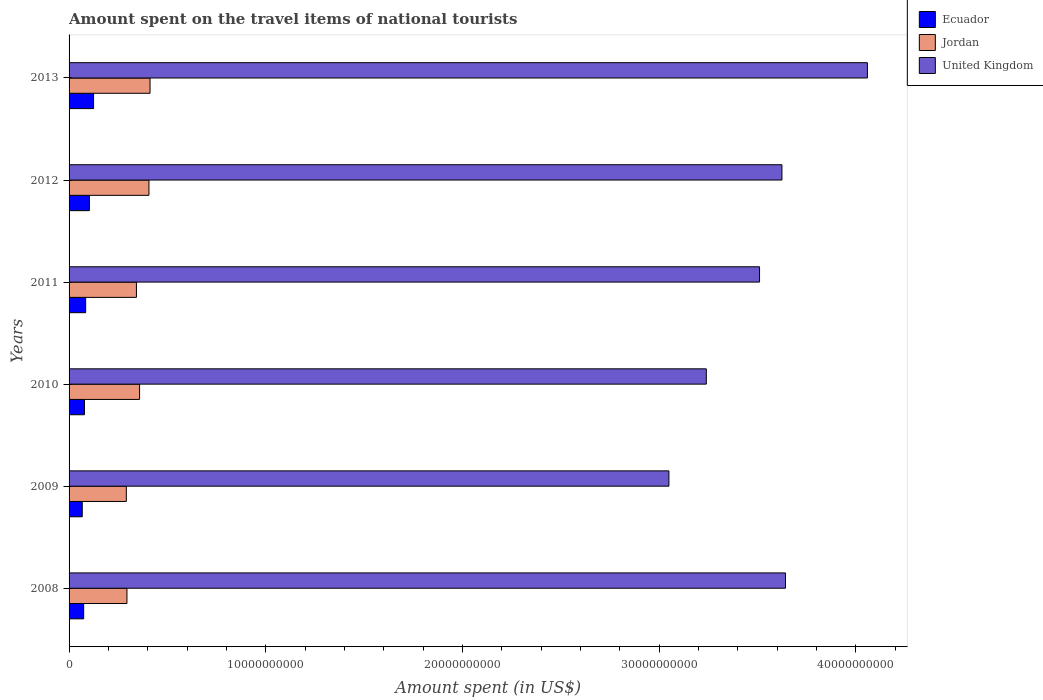Are the number of bars per tick equal to the number of legend labels?
Provide a short and direct response. Yes. How many bars are there on the 2nd tick from the bottom?
Your response must be concise. 3. What is the amount spent on the travel items of national tourists in Ecuador in 2009?
Offer a very short reply. 6.70e+08. Across all years, what is the maximum amount spent on the travel items of national tourists in Jordan?
Offer a very short reply. 4.12e+09. Across all years, what is the minimum amount spent on the travel items of national tourists in Ecuador?
Give a very brief answer. 6.70e+08. In which year was the amount spent on the travel items of national tourists in United Kingdom maximum?
Offer a terse response. 2013. What is the total amount spent on the travel items of national tourists in United Kingdom in the graph?
Give a very brief answer. 2.11e+11. What is the difference between the amount spent on the travel items of national tourists in United Kingdom in 2009 and that in 2012?
Keep it short and to the point. -5.75e+09. What is the difference between the amount spent on the travel items of national tourists in Ecuador in 2009 and the amount spent on the travel items of national tourists in Jordan in 2008?
Ensure brevity in your answer.  -2.27e+09. What is the average amount spent on the travel items of national tourists in United Kingdom per year?
Give a very brief answer. 3.52e+1. In the year 2008, what is the difference between the amount spent on the travel items of national tourists in United Kingdom and amount spent on the travel items of national tourists in Ecuador?
Give a very brief answer. 3.57e+1. In how many years, is the amount spent on the travel items of national tourists in Jordan greater than 10000000000 US$?
Your answer should be compact. 0. What is the ratio of the amount spent on the travel items of national tourists in United Kingdom in 2010 to that in 2013?
Make the answer very short. 0.8. Is the amount spent on the travel items of national tourists in United Kingdom in 2010 less than that in 2013?
Your answer should be very brief. Yes. Is the difference between the amount spent on the travel items of national tourists in United Kingdom in 2009 and 2012 greater than the difference between the amount spent on the travel items of national tourists in Ecuador in 2009 and 2012?
Your response must be concise. No. What is the difference between the highest and the second highest amount spent on the travel items of national tourists in United Kingdom?
Your answer should be compact. 4.16e+09. What is the difference between the highest and the lowest amount spent on the travel items of national tourists in Ecuador?
Keep it short and to the point. 5.76e+08. In how many years, is the amount spent on the travel items of national tourists in Jordan greater than the average amount spent on the travel items of national tourists in Jordan taken over all years?
Make the answer very short. 3. What does the 1st bar from the top in 2012 represents?
Ensure brevity in your answer.  United Kingdom. What does the 1st bar from the bottom in 2013 represents?
Your response must be concise. Ecuador. Is it the case that in every year, the sum of the amount spent on the travel items of national tourists in Jordan and amount spent on the travel items of national tourists in Ecuador is greater than the amount spent on the travel items of national tourists in United Kingdom?
Your response must be concise. No. How many years are there in the graph?
Provide a short and direct response. 6. What is the title of the graph?
Provide a succinct answer. Amount spent on the travel items of national tourists. What is the label or title of the X-axis?
Keep it short and to the point. Amount spent (in US$). What is the Amount spent (in US$) of Ecuador in 2008?
Give a very brief answer. 7.42e+08. What is the Amount spent (in US$) of Jordan in 2008?
Your answer should be very brief. 2.94e+09. What is the Amount spent (in US$) of United Kingdom in 2008?
Keep it short and to the point. 3.64e+1. What is the Amount spent (in US$) in Ecuador in 2009?
Provide a succinct answer. 6.70e+08. What is the Amount spent (in US$) of Jordan in 2009?
Provide a short and direct response. 2.91e+09. What is the Amount spent (in US$) in United Kingdom in 2009?
Give a very brief answer. 3.05e+1. What is the Amount spent (in US$) of Ecuador in 2010?
Provide a short and direct response. 7.81e+08. What is the Amount spent (in US$) in Jordan in 2010?
Ensure brevity in your answer.  3.58e+09. What is the Amount spent (in US$) in United Kingdom in 2010?
Provide a succinct answer. 3.24e+1. What is the Amount spent (in US$) in Ecuador in 2011?
Provide a short and direct response. 8.43e+08. What is the Amount spent (in US$) in Jordan in 2011?
Provide a short and direct response. 3.42e+09. What is the Amount spent (in US$) of United Kingdom in 2011?
Ensure brevity in your answer.  3.51e+1. What is the Amount spent (in US$) in Ecuador in 2012?
Give a very brief answer. 1.03e+09. What is the Amount spent (in US$) in Jordan in 2012?
Ensure brevity in your answer.  4.06e+09. What is the Amount spent (in US$) of United Kingdom in 2012?
Keep it short and to the point. 3.62e+1. What is the Amount spent (in US$) of Ecuador in 2013?
Provide a short and direct response. 1.25e+09. What is the Amount spent (in US$) of Jordan in 2013?
Your response must be concise. 4.12e+09. What is the Amount spent (in US$) of United Kingdom in 2013?
Your answer should be very brief. 4.06e+1. Across all years, what is the maximum Amount spent (in US$) in Ecuador?
Your response must be concise. 1.25e+09. Across all years, what is the maximum Amount spent (in US$) of Jordan?
Your answer should be very brief. 4.12e+09. Across all years, what is the maximum Amount spent (in US$) in United Kingdom?
Give a very brief answer. 4.06e+1. Across all years, what is the minimum Amount spent (in US$) in Ecuador?
Make the answer very short. 6.70e+08. Across all years, what is the minimum Amount spent (in US$) of Jordan?
Make the answer very short. 2.91e+09. Across all years, what is the minimum Amount spent (in US$) of United Kingdom?
Offer a terse response. 3.05e+1. What is the total Amount spent (in US$) in Ecuador in the graph?
Offer a terse response. 5.32e+09. What is the total Amount spent (in US$) in Jordan in the graph?
Offer a very short reply. 2.10e+1. What is the total Amount spent (in US$) in United Kingdom in the graph?
Offer a terse response. 2.11e+11. What is the difference between the Amount spent (in US$) of Ecuador in 2008 and that in 2009?
Make the answer very short. 7.20e+07. What is the difference between the Amount spent (in US$) of Jordan in 2008 and that in 2009?
Offer a terse response. 3.20e+07. What is the difference between the Amount spent (in US$) of United Kingdom in 2008 and that in 2009?
Your answer should be compact. 5.93e+09. What is the difference between the Amount spent (in US$) of Ecuador in 2008 and that in 2010?
Offer a terse response. -3.90e+07. What is the difference between the Amount spent (in US$) of Jordan in 2008 and that in 2010?
Provide a succinct answer. -6.42e+08. What is the difference between the Amount spent (in US$) of United Kingdom in 2008 and that in 2010?
Keep it short and to the point. 4.02e+09. What is the difference between the Amount spent (in US$) of Ecuador in 2008 and that in 2011?
Offer a very short reply. -1.01e+08. What is the difference between the Amount spent (in US$) in Jordan in 2008 and that in 2011?
Your answer should be very brief. -4.82e+08. What is the difference between the Amount spent (in US$) in United Kingdom in 2008 and that in 2011?
Offer a terse response. 1.32e+09. What is the difference between the Amount spent (in US$) of Ecuador in 2008 and that in 2012?
Make the answer very short. -2.91e+08. What is the difference between the Amount spent (in US$) of Jordan in 2008 and that in 2012?
Provide a short and direct response. -1.12e+09. What is the difference between the Amount spent (in US$) in United Kingdom in 2008 and that in 2012?
Offer a terse response. 1.80e+08. What is the difference between the Amount spent (in US$) in Ecuador in 2008 and that in 2013?
Provide a short and direct response. -5.04e+08. What is the difference between the Amount spent (in US$) of Jordan in 2008 and that in 2013?
Your answer should be compact. -1.17e+09. What is the difference between the Amount spent (in US$) of United Kingdom in 2008 and that in 2013?
Your answer should be compact. -4.16e+09. What is the difference between the Amount spent (in US$) of Ecuador in 2009 and that in 2010?
Make the answer very short. -1.11e+08. What is the difference between the Amount spent (in US$) of Jordan in 2009 and that in 2010?
Make the answer very short. -6.74e+08. What is the difference between the Amount spent (in US$) in United Kingdom in 2009 and that in 2010?
Give a very brief answer. -1.90e+09. What is the difference between the Amount spent (in US$) of Ecuador in 2009 and that in 2011?
Keep it short and to the point. -1.73e+08. What is the difference between the Amount spent (in US$) in Jordan in 2009 and that in 2011?
Your answer should be compact. -5.14e+08. What is the difference between the Amount spent (in US$) of United Kingdom in 2009 and that in 2011?
Offer a terse response. -4.61e+09. What is the difference between the Amount spent (in US$) of Ecuador in 2009 and that in 2012?
Your response must be concise. -3.63e+08. What is the difference between the Amount spent (in US$) in Jordan in 2009 and that in 2012?
Provide a short and direct response. -1.15e+09. What is the difference between the Amount spent (in US$) of United Kingdom in 2009 and that in 2012?
Provide a short and direct response. -5.75e+09. What is the difference between the Amount spent (in US$) of Ecuador in 2009 and that in 2013?
Your answer should be compact. -5.76e+08. What is the difference between the Amount spent (in US$) in Jordan in 2009 and that in 2013?
Your answer should be very brief. -1.21e+09. What is the difference between the Amount spent (in US$) of United Kingdom in 2009 and that in 2013?
Your answer should be compact. -1.01e+1. What is the difference between the Amount spent (in US$) of Ecuador in 2010 and that in 2011?
Provide a short and direct response. -6.20e+07. What is the difference between the Amount spent (in US$) in Jordan in 2010 and that in 2011?
Provide a succinct answer. 1.60e+08. What is the difference between the Amount spent (in US$) in United Kingdom in 2010 and that in 2011?
Your answer should be compact. -2.71e+09. What is the difference between the Amount spent (in US$) in Ecuador in 2010 and that in 2012?
Offer a very short reply. -2.52e+08. What is the difference between the Amount spent (in US$) of Jordan in 2010 and that in 2012?
Offer a terse response. -4.76e+08. What is the difference between the Amount spent (in US$) of United Kingdom in 2010 and that in 2012?
Your response must be concise. -3.84e+09. What is the difference between the Amount spent (in US$) of Ecuador in 2010 and that in 2013?
Make the answer very short. -4.65e+08. What is the difference between the Amount spent (in US$) in Jordan in 2010 and that in 2013?
Ensure brevity in your answer.  -5.32e+08. What is the difference between the Amount spent (in US$) in United Kingdom in 2010 and that in 2013?
Ensure brevity in your answer.  -8.19e+09. What is the difference between the Amount spent (in US$) of Ecuador in 2011 and that in 2012?
Your answer should be very brief. -1.90e+08. What is the difference between the Amount spent (in US$) in Jordan in 2011 and that in 2012?
Make the answer very short. -6.36e+08. What is the difference between the Amount spent (in US$) of United Kingdom in 2011 and that in 2012?
Make the answer very short. -1.14e+09. What is the difference between the Amount spent (in US$) in Ecuador in 2011 and that in 2013?
Your answer should be very brief. -4.03e+08. What is the difference between the Amount spent (in US$) of Jordan in 2011 and that in 2013?
Your response must be concise. -6.92e+08. What is the difference between the Amount spent (in US$) of United Kingdom in 2011 and that in 2013?
Offer a very short reply. -5.48e+09. What is the difference between the Amount spent (in US$) of Ecuador in 2012 and that in 2013?
Make the answer very short. -2.13e+08. What is the difference between the Amount spent (in US$) of Jordan in 2012 and that in 2013?
Ensure brevity in your answer.  -5.60e+07. What is the difference between the Amount spent (in US$) of United Kingdom in 2012 and that in 2013?
Your answer should be very brief. -4.34e+09. What is the difference between the Amount spent (in US$) of Ecuador in 2008 and the Amount spent (in US$) of Jordan in 2009?
Provide a succinct answer. -2.17e+09. What is the difference between the Amount spent (in US$) of Ecuador in 2008 and the Amount spent (in US$) of United Kingdom in 2009?
Provide a succinct answer. -2.98e+1. What is the difference between the Amount spent (in US$) in Jordan in 2008 and the Amount spent (in US$) in United Kingdom in 2009?
Offer a terse response. -2.76e+1. What is the difference between the Amount spent (in US$) of Ecuador in 2008 and the Amount spent (in US$) of Jordan in 2010?
Ensure brevity in your answer.  -2.84e+09. What is the difference between the Amount spent (in US$) in Ecuador in 2008 and the Amount spent (in US$) in United Kingdom in 2010?
Give a very brief answer. -3.17e+1. What is the difference between the Amount spent (in US$) of Jordan in 2008 and the Amount spent (in US$) of United Kingdom in 2010?
Your answer should be very brief. -2.95e+1. What is the difference between the Amount spent (in US$) in Ecuador in 2008 and the Amount spent (in US$) in Jordan in 2011?
Give a very brief answer. -2.68e+09. What is the difference between the Amount spent (in US$) in Ecuador in 2008 and the Amount spent (in US$) in United Kingdom in 2011?
Ensure brevity in your answer.  -3.44e+1. What is the difference between the Amount spent (in US$) in Jordan in 2008 and the Amount spent (in US$) in United Kingdom in 2011?
Offer a terse response. -3.22e+1. What is the difference between the Amount spent (in US$) of Ecuador in 2008 and the Amount spent (in US$) of Jordan in 2012?
Give a very brief answer. -3.32e+09. What is the difference between the Amount spent (in US$) in Ecuador in 2008 and the Amount spent (in US$) in United Kingdom in 2012?
Provide a succinct answer. -3.55e+1. What is the difference between the Amount spent (in US$) in Jordan in 2008 and the Amount spent (in US$) in United Kingdom in 2012?
Your answer should be compact. -3.33e+1. What is the difference between the Amount spent (in US$) of Ecuador in 2008 and the Amount spent (in US$) of Jordan in 2013?
Give a very brief answer. -3.38e+09. What is the difference between the Amount spent (in US$) in Ecuador in 2008 and the Amount spent (in US$) in United Kingdom in 2013?
Your answer should be compact. -3.98e+1. What is the difference between the Amount spent (in US$) of Jordan in 2008 and the Amount spent (in US$) of United Kingdom in 2013?
Your response must be concise. -3.76e+1. What is the difference between the Amount spent (in US$) in Ecuador in 2009 and the Amount spent (in US$) in Jordan in 2010?
Your answer should be very brief. -2.92e+09. What is the difference between the Amount spent (in US$) of Ecuador in 2009 and the Amount spent (in US$) of United Kingdom in 2010?
Your response must be concise. -3.17e+1. What is the difference between the Amount spent (in US$) in Jordan in 2009 and the Amount spent (in US$) in United Kingdom in 2010?
Give a very brief answer. -2.95e+1. What is the difference between the Amount spent (in US$) in Ecuador in 2009 and the Amount spent (in US$) in Jordan in 2011?
Make the answer very short. -2.76e+09. What is the difference between the Amount spent (in US$) of Ecuador in 2009 and the Amount spent (in US$) of United Kingdom in 2011?
Your answer should be very brief. -3.44e+1. What is the difference between the Amount spent (in US$) in Jordan in 2009 and the Amount spent (in US$) in United Kingdom in 2011?
Offer a very short reply. -3.22e+1. What is the difference between the Amount spent (in US$) in Ecuador in 2009 and the Amount spent (in US$) in Jordan in 2012?
Provide a succinct answer. -3.39e+09. What is the difference between the Amount spent (in US$) in Ecuador in 2009 and the Amount spent (in US$) in United Kingdom in 2012?
Offer a terse response. -3.56e+1. What is the difference between the Amount spent (in US$) in Jordan in 2009 and the Amount spent (in US$) in United Kingdom in 2012?
Provide a succinct answer. -3.33e+1. What is the difference between the Amount spent (in US$) in Ecuador in 2009 and the Amount spent (in US$) in Jordan in 2013?
Give a very brief answer. -3.45e+09. What is the difference between the Amount spent (in US$) in Ecuador in 2009 and the Amount spent (in US$) in United Kingdom in 2013?
Offer a very short reply. -3.99e+1. What is the difference between the Amount spent (in US$) of Jordan in 2009 and the Amount spent (in US$) of United Kingdom in 2013?
Your answer should be very brief. -3.77e+1. What is the difference between the Amount spent (in US$) of Ecuador in 2010 and the Amount spent (in US$) of Jordan in 2011?
Your answer should be very brief. -2.64e+09. What is the difference between the Amount spent (in US$) of Ecuador in 2010 and the Amount spent (in US$) of United Kingdom in 2011?
Provide a short and direct response. -3.43e+1. What is the difference between the Amount spent (in US$) in Jordan in 2010 and the Amount spent (in US$) in United Kingdom in 2011?
Your answer should be compact. -3.15e+1. What is the difference between the Amount spent (in US$) of Ecuador in 2010 and the Amount spent (in US$) of Jordan in 2012?
Your answer should be compact. -3.28e+09. What is the difference between the Amount spent (in US$) of Ecuador in 2010 and the Amount spent (in US$) of United Kingdom in 2012?
Offer a terse response. -3.55e+1. What is the difference between the Amount spent (in US$) of Jordan in 2010 and the Amount spent (in US$) of United Kingdom in 2012?
Ensure brevity in your answer.  -3.27e+1. What is the difference between the Amount spent (in US$) in Ecuador in 2010 and the Amount spent (in US$) in Jordan in 2013?
Offer a very short reply. -3.34e+09. What is the difference between the Amount spent (in US$) of Ecuador in 2010 and the Amount spent (in US$) of United Kingdom in 2013?
Make the answer very short. -3.98e+1. What is the difference between the Amount spent (in US$) of Jordan in 2010 and the Amount spent (in US$) of United Kingdom in 2013?
Your answer should be very brief. -3.70e+1. What is the difference between the Amount spent (in US$) of Ecuador in 2011 and the Amount spent (in US$) of Jordan in 2012?
Offer a very short reply. -3.22e+09. What is the difference between the Amount spent (in US$) in Ecuador in 2011 and the Amount spent (in US$) in United Kingdom in 2012?
Your answer should be compact. -3.54e+1. What is the difference between the Amount spent (in US$) of Jordan in 2011 and the Amount spent (in US$) of United Kingdom in 2012?
Offer a very short reply. -3.28e+1. What is the difference between the Amount spent (in US$) of Ecuador in 2011 and the Amount spent (in US$) of Jordan in 2013?
Offer a very short reply. -3.27e+09. What is the difference between the Amount spent (in US$) of Ecuador in 2011 and the Amount spent (in US$) of United Kingdom in 2013?
Provide a succinct answer. -3.97e+1. What is the difference between the Amount spent (in US$) of Jordan in 2011 and the Amount spent (in US$) of United Kingdom in 2013?
Your answer should be compact. -3.72e+1. What is the difference between the Amount spent (in US$) of Ecuador in 2012 and the Amount spent (in US$) of Jordan in 2013?
Provide a short and direct response. -3.08e+09. What is the difference between the Amount spent (in US$) of Ecuador in 2012 and the Amount spent (in US$) of United Kingdom in 2013?
Make the answer very short. -3.96e+1. What is the difference between the Amount spent (in US$) in Jordan in 2012 and the Amount spent (in US$) in United Kingdom in 2013?
Offer a terse response. -3.65e+1. What is the average Amount spent (in US$) in Ecuador per year?
Provide a short and direct response. 8.86e+08. What is the average Amount spent (in US$) in Jordan per year?
Give a very brief answer. 3.51e+09. What is the average Amount spent (in US$) of United Kingdom per year?
Your response must be concise. 3.52e+1. In the year 2008, what is the difference between the Amount spent (in US$) in Ecuador and Amount spent (in US$) in Jordan?
Provide a short and direct response. -2.20e+09. In the year 2008, what is the difference between the Amount spent (in US$) of Ecuador and Amount spent (in US$) of United Kingdom?
Keep it short and to the point. -3.57e+1. In the year 2008, what is the difference between the Amount spent (in US$) in Jordan and Amount spent (in US$) in United Kingdom?
Your answer should be compact. -3.35e+1. In the year 2009, what is the difference between the Amount spent (in US$) in Ecuador and Amount spent (in US$) in Jordan?
Provide a short and direct response. -2.24e+09. In the year 2009, what is the difference between the Amount spent (in US$) in Ecuador and Amount spent (in US$) in United Kingdom?
Give a very brief answer. -2.98e+1. In the year 2009, what is the difference between the Amount spent (in US$) of Jordan and Amount spent (in US$) of United Kingdom?
Your answer should be very brief. -2.76e+1. In the year 2010, what is the difference between the Amount spent (in US$) of Ecuador and Amount spent (in US$) of Jordan?
Your response must be concise. -2.80e+09. In the year 2010, what is the difference between the Amount spent (in US$) in Ecuador and Amount spent (in US$) in United Kingdom?
Provide a succinct answer. -3.16e+1. In the year 2010, what is the difference between the Amount spent (in US$) in Jordan and Amount spent (in US$) in United Kingdom?
Offer a terse response. -2.88e+1. In the year 2011, what is the difference between the Amount spent (in US$) of Ecuador and Amount spent (in US$) of Jordan?
Give a very brief answer. -2.58e+09. In the year 2011, what is the difference between the Amount spent (in US$) in Ecuador and Amount spent (in US$) in United Kingdom?
Provide a short and direct response. -3.43e+1. In the year 2011, what is the difference between the Amount spent (in US$) of Jordan and Amount spent (in US$) of United Kingdom?
Provide a short and direct response. -3.17e+1. In the year 2012, what is the difference between the Amount spent (in US$) of Ecuador and Amount spent (in US$) of Jordan?
Keep it short and to the point. -3.03e+09. In the year 2012, what is the difference between the Amount spent (in US$) in Ecuador and Amount spent (in US$) in United Kingdom?
Offer a very short reply. -3.52e+1. In the year 2012, what is the difference between the Amount spent (in US$) of Jordan and Amount spent (in US$) of United Kingdom?
Offer a very short reply. -3.22e+1. In the year 2013, what is the difference between the Amount spent (in US$) in Ecuador and Amount spent (in US$) in Jordan?
Provide a short and direct response. -2.87e+09. In the year 2013, what is the difference between the Amount spent (in US$) in Ecuador and Amount spent (in US$) in United Kingdom?
Provide a succinct answer. -3.93e+1. In the year 2013, what is the difference between the Amount spent (in US$) of Jordan and Amount spent (in US$) of United Kingdom?
Your answer should be very brief. -3.65e+1. What is the ratio of the Amount spent (in US$) in Ecuador in 2008 to that in 2009?
Make the answer very short. 1.11. What is the ratio of the Amount spent (in US$) of Jordan in 2008 to that in 2009?
Offer a very short reply. 1.01. What is the ratio of the Amount spent (in US$) of United Kingdom in 2008 to that in 2009?
Provide a short and direct response. 1.19. What is the ratio of the Amount spent (in US$) of Ecuador in 2008 to that in 2010?
Provide a short and direct response. 0.95. What is the ratio of the Amount spent (in US$) in Jordan in 2008 to that in 2010?
Your answer should be very brief. 0.82. What is the ratio of the Amount spent (in US$) in United Kingdom in 2008 to that in 2010?
Provide a short and direct response. 1.12. What is the ratio of the Amount spent (in US$) in Ecuador in 2008 to that in 2011?
Provide a succinct answer. 0.88. What is the ratio of the Amount spent (in US$) in Jordan in 2008 to that in 2011?
Your response must be concise. 0.86. What is the ratio of the Amount spent (in US$) of United Kingdom in 2008 to that in 2011?
Give a very brief answer. 1.04. What is the ratio of the Amount spent (in US$) of Ecuador in 2008 to that in 2012?
Provide a short and direct response. 0.72. What is the ratio of the Amount spent (in US$) of Jordan in 2008 to that in 2012?
Ensure brevity in your answer.  0.72. What is the ratio of the Amount spent (in US$) in United Kingdom in 2008 to that in 2012?
Your response must be concise. 1. What is the ratio of the Amount spent (in US$) in Ecuador in 2008 to that in 2013?
Your answer should be compact. 0.6. What is the ratio of the Amount spent (in US$) in Jordan in 2008 to that in 2013?
Give a very brief answer. 0.71. What is the ratio of the Amount spent (in US$) in United Kingdom in 2008 to that in 2013?
Provide a succinct answer. 0.9. What is the ratio of the Amount spent (in US$) of Ecuador in 2009 to that in 2010?
Your response must be concise. 0.86. What is the ratio of the Amount spent (in US$) in Jordan in 2009 to that in 2010?
Offer a very short reply. 0.81. What is the ratio of the Amount spent (in US$) of United Kingdom in 2009 to that in 2010?
Provide a short and direct response. 0.94. What is the ratio of the Amount spent (in US$) in Ecuador in 2009 to that in 2011?
Offer a very short reply. 0.79. What is the ratio of the Amount spent (in US$) of Jordan in 2009 to that in 2011?
Ensure brevity in your answer.  0.85. What is the ratio of the Amount spent (in US$) in United Kingdom in 2009 to that in 2011?
Your answer should be very brief. 0.87. What is the ratio of the Amount spent (in US$) in Ecuador in 2009 to that in 2012?
Provide a succinct answer. 0.65. What is the ratio of the Amount spent (in US$) of Jordan in 2009 to that in 2012?
Ensure brevity in your answer.  0.72. What is the ratio of the Amount spent (in US$) in United Kingdom in 2009 to that in 2012?
Your response must be concise. 0.84. What is the ratio of the Amount spent (in US$) in Ecuador in 2009 to that in 2013?
Your answer should be very brief. 0.54. What is the ratio of the Amount spent (in US$) of Jordan in 2009 to that in 2013?
Your answer should be very brief. 0.71. What is the ratio of the Amount spent (in US$) of United Kingdom in 2009 to that in 2013?
Give a very brief answer. 0.75. What is the ratio of the Amount spent (in US$) of Ecuador in 2010 to that in 2011?
Offer a terse response. 0.93. What is the ratio of the Amount spent (in US$) of Jordan in 2010 to that in 2011?
Offer a terse response. 1.05. What is the ratio of the Amount spent (in US$) in United Kingdom in 2010 to that in 2011?
Your answer should be compact. 0.92. What is the ratio of the Amount spent (in US$) of Ecuador in 2010 to that in 2012?
Your answer should be very brief. 0.76. What is the ratio of the Amount spent (in US$) of Jordan in 2010 to that in 2012?
Give a very brief answer. 0.88. What is the ratio of the Amount spent (in US$) of United Kingdom in 2010 to that in 2012?
Provide a short and direct response. 0.89. What is the ratio of the Amount spent (in US$) of Ecuador in 2010 to that in 2013?
Offer a terse response. 0.63. What is the ratio of the Amount spent (in US$) of Jordan in 2010 to that in 2013?
Ensure brevity in your answer.  0.87. What is the ratio of the Amount spent (in US$) in United Kingdom in 2010 to that in 2013?
Your answer should be compact. 0.8. What is the ratio of the Amount spent (in US$) of Ecuador in 2011 to that in 2012?
Provide a succinct answer. 0.82. What is the ratio of the Amount spent (in US$) of Jordan in 2011 to that in 2012?
Ensure brevity in your answer.  0.84. What is the ratio of the Amount spent (in US$) in United Kingdom in 2011 to that in 2012?
Provide a short and direct response. 0.97. What is the ratio of the Amount spent (in US$) of Ecuador in 2011 to that in 2013?
Provide a succinct answer. 0.68. What is the ratio of the Amount spent (in US$) of Jordan in 2011 to that in 2013?
Provide a short and direct response. 0.83. What is the ratio of the Amount spent (in US$) in United Kingdom in 2011 to that in 2013?
Provide a short and direct response. 0.86. What is the ratio of the Amount spent (in US$) in Ecuador in 2012 to that in 2013?
Your response must be concise. 0.83. What is the ratio of the Amount spent (in US$) in Jordan in 2012 to that in 2013?
Keep it short and to the point. 0.99. What is the ratio of the Amount spent (in US$) of United Kingdom in 2012 to that in 2013?
Give a very brief answer. 0.89. What is the difference between the highest and the second highest Amount spent (in US$) in Ecuador?
Your answer should be compact. 2.13e+08. What is the difference between the highest and the second highest Amount spent (in US$) of Jordan?
Ensure brevity in your answer.  5.60e+07. What is the difference between the highest and the second highest Amount spent (in US$) in United Kingdom?
Provide a succinct answer. 4.16e+09. What is the difference between the highest and the lowest Amount spent (in US$) in Ecuador?
Make the answer very short. 5.76e+08. What is the difference between the highest and the lowest Amount spent (in US$) of Jordan?
Ensure brevity in your answer.  1.21e+09. What is the difference between the highest and the lowest Amount spent (in US$) in United Kingdom?
Give a very brief answer. 1.01e+1. 